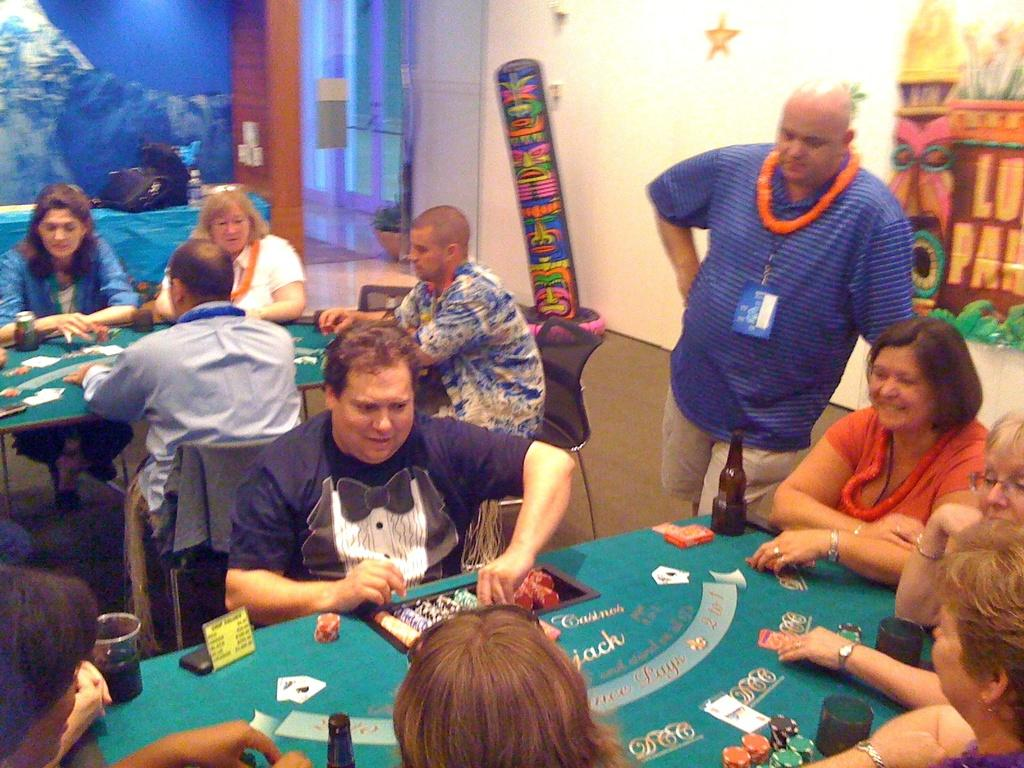What are the people in the image doing around the table? The people are sitting around a table and playing cards in the image. Can you describe the man's position in the image? There is a man standing on the right side of the image. What is the man doing in the image? The man is staring at the people playing cards. What type of meat is being served in the image? There is no meat present in the image; it features people playing cards around a table. Can you describe the spaceship in the image? There is no spaceship present in the image; it features people playing cards around a table and a man standing nearby. 